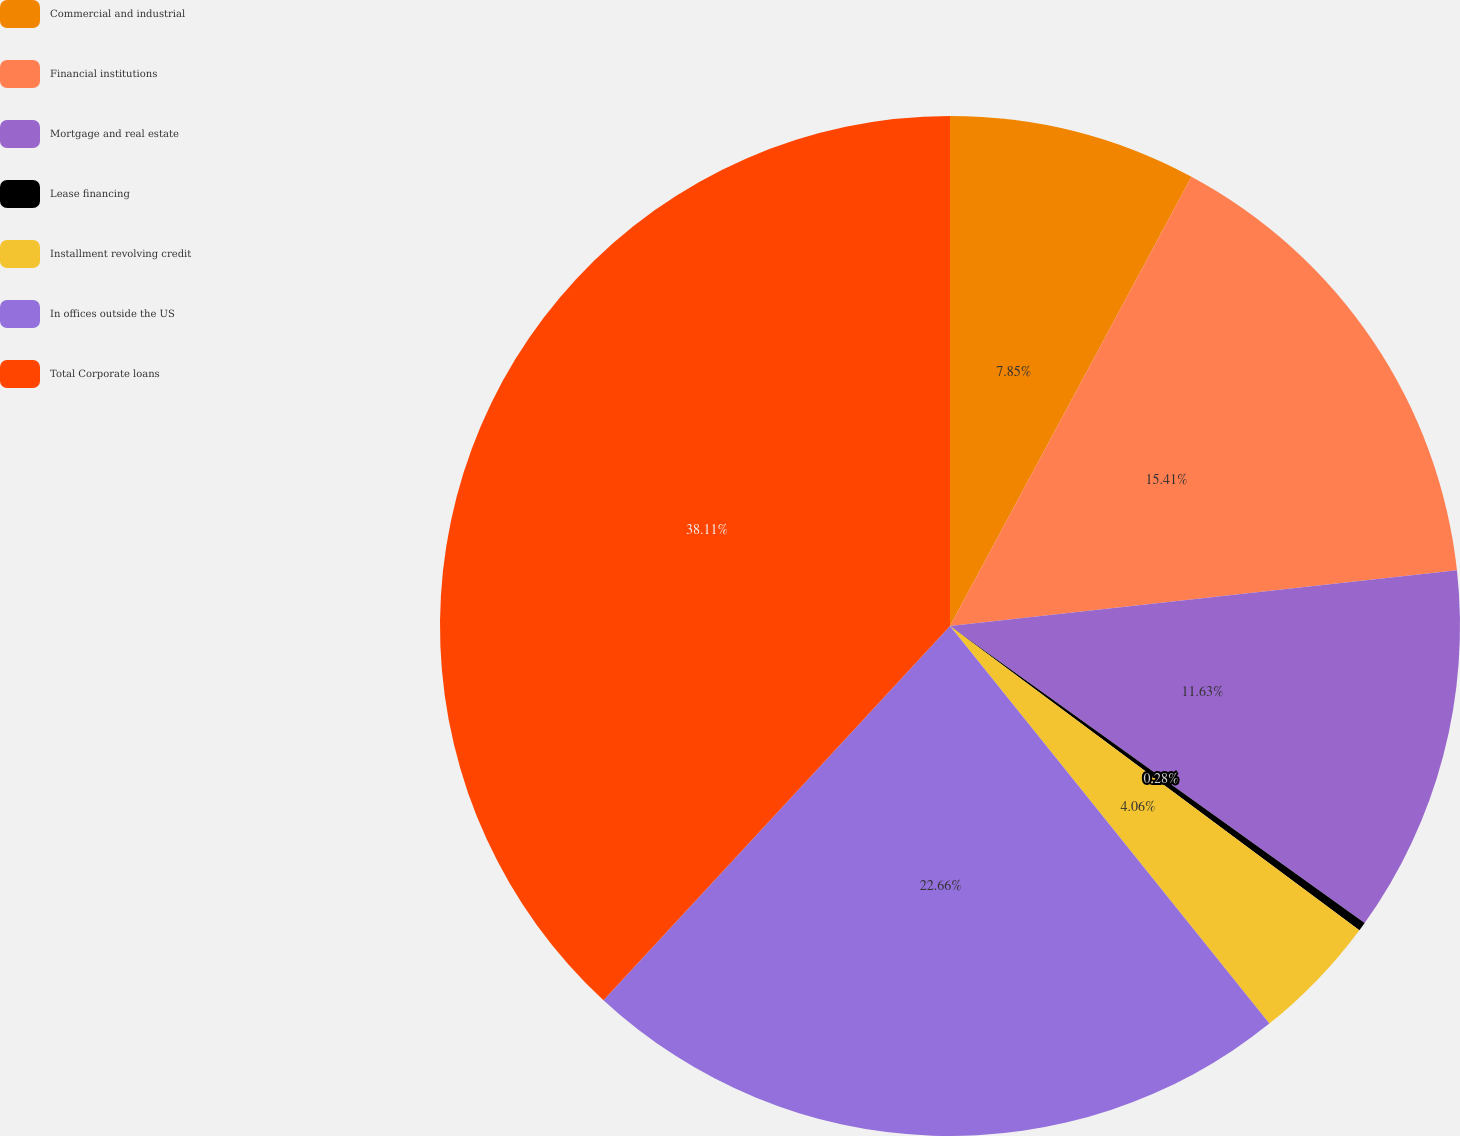Convert chart to OTSL. <chart><loc_0><loc_0><loc_500><loc_500><pie_chart><fcel>Commercial and industrial<fcel>Financial institutions<fcel>Mortgage and real estate<fcel>Lease financing<fcel>Installment revolving credit<fcel>In offices outside the US<fcel>Total Corporate loans<nl><fcel>7.85%<fcel>15.41%<fcel>11.63%<fcel>0.28%<fcel>4.06%<fcel>22.66%<fcel>38.11%<nl></chart> 